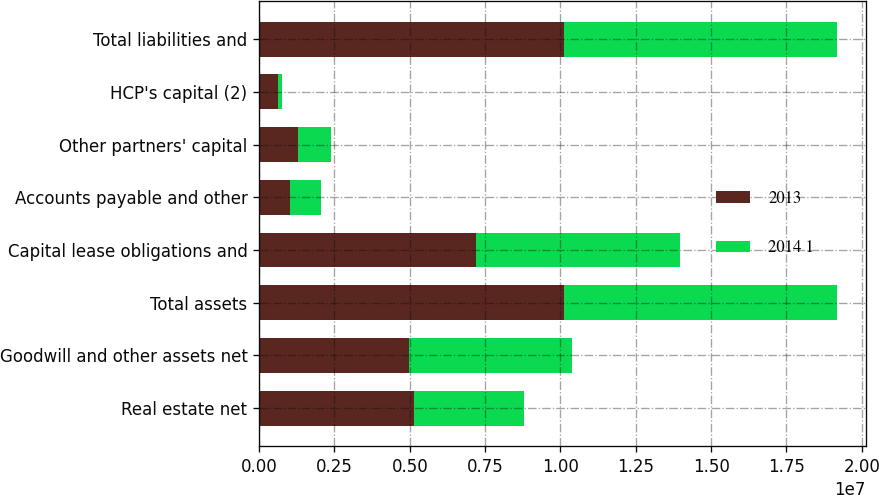Convert chart to OTSL. <chart><loc_0><loc_0><loc_500><loc_500><stacked_bar_chart><ecel><fcel>Real estate net<fcel>Goodwill and other assets net<fcel>Total assets<fcel>Capital lease obligations and<fcel>Accounts payable and other<fcel>Other partners' capital<fcel>HCP's capital (2)<fcel>Total liabilities and<nl><fcel>2013<fcel>5.13459e+06<fcel>4.98631e+06<fcel>1.01209e+07<fcel>7.19794e+06<fcel>1.01591e+06<fcel>1.28141e+06<fcel>625632<fcel>1.01209e+07<nl><fcel>2014 1<fcel>3.66245e+06<fcel>5.38455e+06<fcel>9.047e+06<fcel>6.76882e+06<fcel>1.04526e+06<fcel>1.09823e+06<fcel>134700<fcel>9.047e+06<nl></chart> 